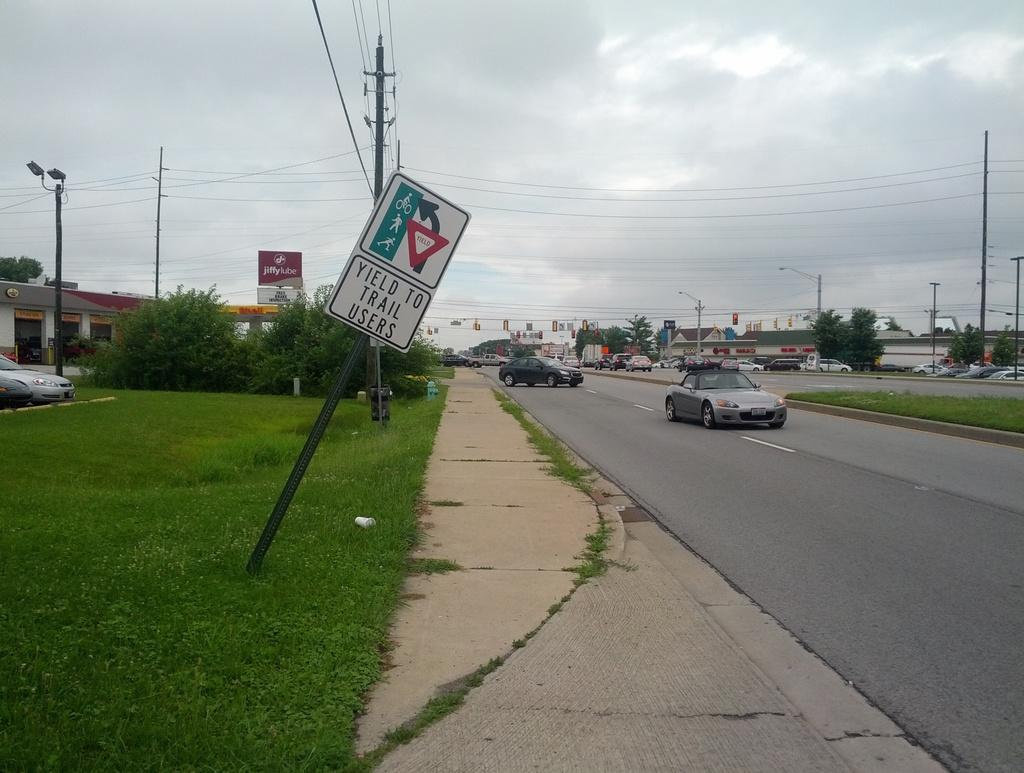<image>
Share a concise interpretation of the image provided. Along a road, a sign directing drivers to yield to trail users is bending over towards the sidewalk. 